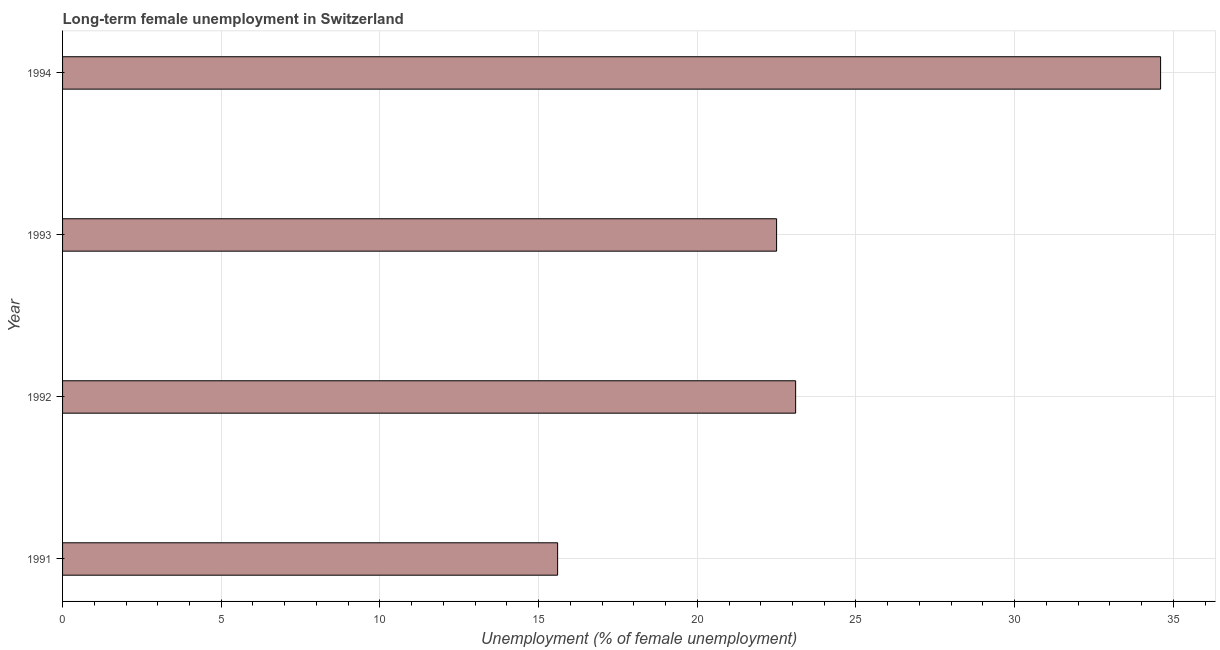Does the graph contain grids?
Your response must be concise. Yes. What is the title of the graph?
Offer a very short reply. Long-term female unemployment in Switzerland. What is the label or title of the X-axis?
Provide a short and direct response. Unemployment (% of female unemployment). What is the label or title of the Y-axis?
Provide a succinct answer. Year. What is the long-term female unemployment in 1992?
Offer a terse response. 23.1. Across all years, what is the maximum long-term female unemployment?
Your response must be concise. 34.6. Across all years, what is the minimum long-term female unemployment?
Keep it short and to the point. 15.6. In which year was the long-term female unemployment maximum?
Your response must be concise. 1994. What is the sum of the long-term female unemployment?
Provide a short and direct response. 95.8. What is the difference between the long-term female unemployment in 1991 and 1993?
Provide a succinct answer. -6.9. What is the average long-term female unemployment per year?
Keep it short and to the point. 23.95. What is the median long-term female unemployment?
Make the answer very short. 22.8. What is the ratio of the long-term female unemployment in 1991 to that in 1993?
Your answer should be compact. 0.69. Is the difference between the long-term female unemployment in 1992 and 1993 greater than the difference between any two years?
Your answer should be very brief. No. What is the difference between the highest and the second highest long-term female unemployment?
Make the answer very short. 11.5. Is the sum of the long-term female unemployment in 1992 and 1994 greater than the maximum long-term female unemployment across all years?
Give a very brief answer. Yes. In how many years, is the long-term female unemployment greater than the average long-term female unemployment taken over all years?
Provide a succinct answer. 1. How many bars are there?
Your answer should be compact. 4. What is the difference between two consecutive major ticks on the X-axis?
Offer a terse response. 5. Are the values on the major ticks of X-axis written in scientific E-notation?
Your answer should be compact. No. What is the Unemployment (% of female unemployment) in 1991?
Provide a succinct answer. 15.6. What is the Unemployment (% of female unemployment) in 1992?
Provide a short and direct response. 23.1. What is the Unemployment (% of female unemployment) of 1993?
Ensure brevity in your answer.  22.5. What is the Unemployment (% of female unemployment) in 1994?
Provide a succinct answer. 34.6. What is the difference between the Unemployment (% of female unemployment) in 1991 and 1992?
Ensure brevity in your answer.  -7.5. What is the difference between the Unemployment (% of female unemployment) in 1992 and 1993?
Offer a terse response. 0.6. What is the difference between the Unemployment (% of female unemployment) in 1992 and 1994?
Your answer should be compact. -11.5. What is the ratio of the Unemployment (% of female unemployment) in 1991 to that in 1992?
Keep it short and to the point. 0.68. What is the ratio of the Unemployment (% of female unemployment) in 1991 to that in 1993?
Keep it short and to the point. 0.69. What is the ratio of the Unemployment (% of female unemployment) in 1991 to that in 1994?
Your answer should be compact. 0.45. What is the ratio of the Unemployment (% of female unemployment) in 1992 to that in 1993?
Provide a succinct answer. 1.03. What is the ratio of the Unemployment (% of female unemployment) in 1992 to that in 1994?
Your answer should be very brief. 0.67. What is the ratio of the Unemployment (% of female unemployment) in 1993 to that in 1994?
Your answer should be very brief. 0.65. 